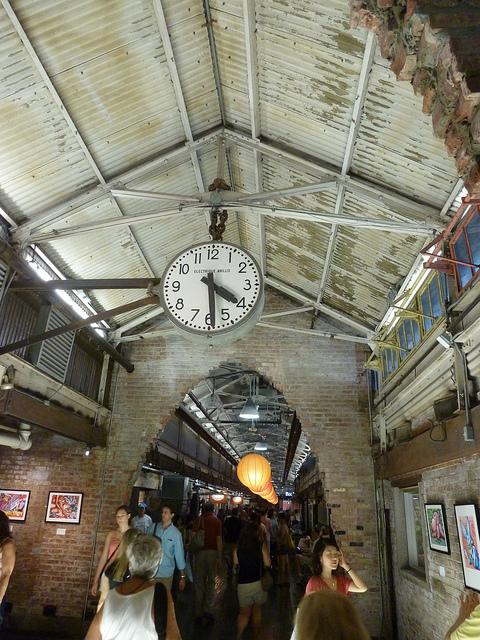What time is it approximately? Please explain your reasoning. 430. The time is approximately 4:30. 